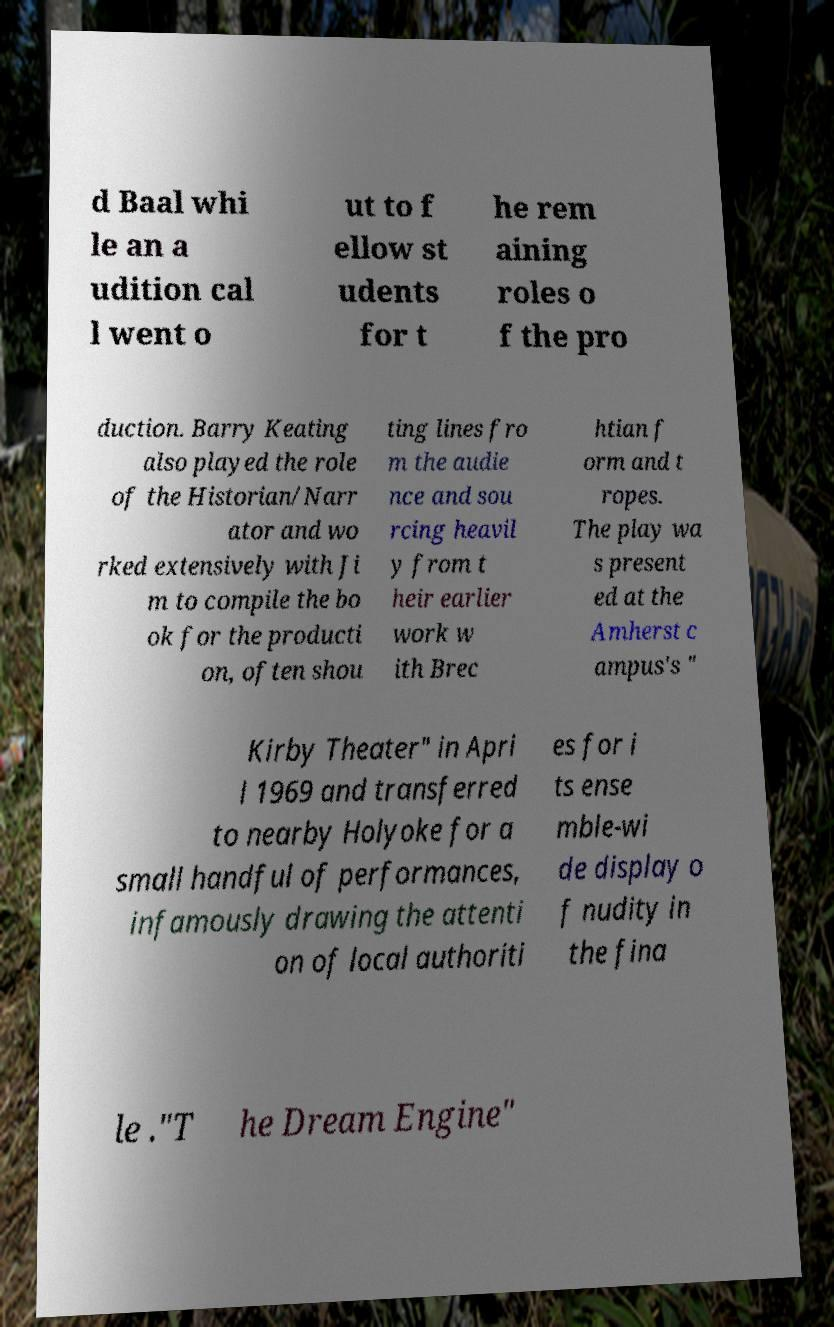Can you read and provide the text displayed in the image?This photo seems to have some interesting text. Can you extract and type it out for me? d Baal whi le an a udition cal l went o ut to f ellow st udents for t he rem aining roles o f the pro duction. Barry Keating also played the role of the Historian/Narr ator and wo rked extensively with Ji m to compile the bo ok for the producti on, often shou ting lines fro m the audie nce and sou rcing heavil y from t heir earlier work w ith Brec htian f orm and t ropes. The play wa s present ed at the Amherst c ampus's " Kirby Theater" in Apri l 1969 and transferred to nearby Holyoke for a small handful of performances, infamously drawing the attenti on of local authoriti es for i ts ense mble-wi de display o f nudity in the fina le ."T he Dream Engine" 